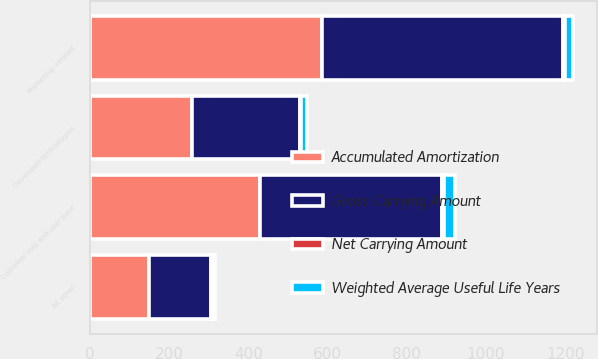Convert chart. <chart><loc_0><loc_0><loc_500><loc_500><stacked_bar_chart><ecel><fcel>Customer lists and user base<fcel>Marketing- related<fcel>Developed technologies<fcel>All other<nl><fcel>Gross Carrying Amount<fcel>458<fcel>607<fcel>273<fcel>156<nl><fcel>Accumulated Amortization<fcel>430<fcel>587<fcel>258<fcel>150<nl><fcel>Weighted Average Useful Life Years<fcel>28<fcel>20<fcel>15<fcel>6<nl><fcel>Net Carrying Amount<fcel>5<fcel>5<fcel>3<fcel>4<nl></chart> 